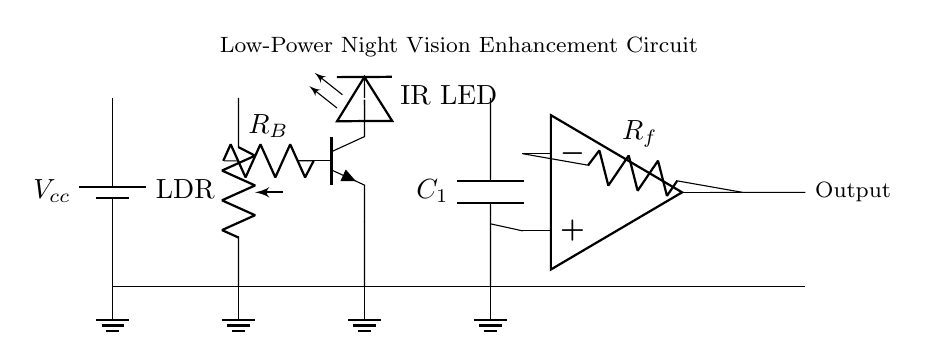What is the type of light sensor used in this circuit? The light sensor in the circuit is a photoresistor, commonly referred to as an LDR. It is identified in the diagram as LDR, indicating it is used to detect light levels, which can help adjust the circuit's functionality based on ambient light.
Answer: photoresistor What is the function of the IR LED in this circuit? The IR LED emits infrared light, which is essential for night vision applications. It is designed to illuminate the area in low-light conditions without giving away the position of the operator, making it ideal for covert operations.
Answer: infrared light emission What does the op-amp do in this circuit? The operational amplifier (op-amp) is used to amplify the signal from the circuit, enhancing the output based on the inputs it receives. In this context, it processes the feedback from the light sensor and improves the output signal for more effective night vision enhancement.
Answer: amplifies the signal What is the purpose of the capacitor in this circuit? The capacitor acts as a filter for smoothing out voltage fluctuations in the circuit, providing stability to the signal. This is particularly important in low-power applications to ensure consistent performance during covert operations.
Answer: stabilize voltage fluctuations How does the transistor function in this circuit? The transistor operates as a switch or amplifier, controlling the current flow to the IR LED based on the signal from the photoresistor. When the light level drops, the transistor allows more current to flow, turning on the IR LED to enhance visibility in the dark.
Answer: switches and amplifies current What type of power supply is used in this circuit? The circuit uses a battery as the power supply, which is indicated by the battery symbol labeled Vcc. This type of supply is commonly used in portable applications for low-power devices, such as night vision circuits.
Answer: battery What role does Rf play in the op-amp section of the circuit? The resistor Rf in the feedback loop of the op-amp controls the gain of the amplifier. It determines how much the signal is amplified, allowing the operator to adjust the sensitivity and performance of the night vision enhancement depending on the ambient light conditions.
Answer: controls amplification gain 